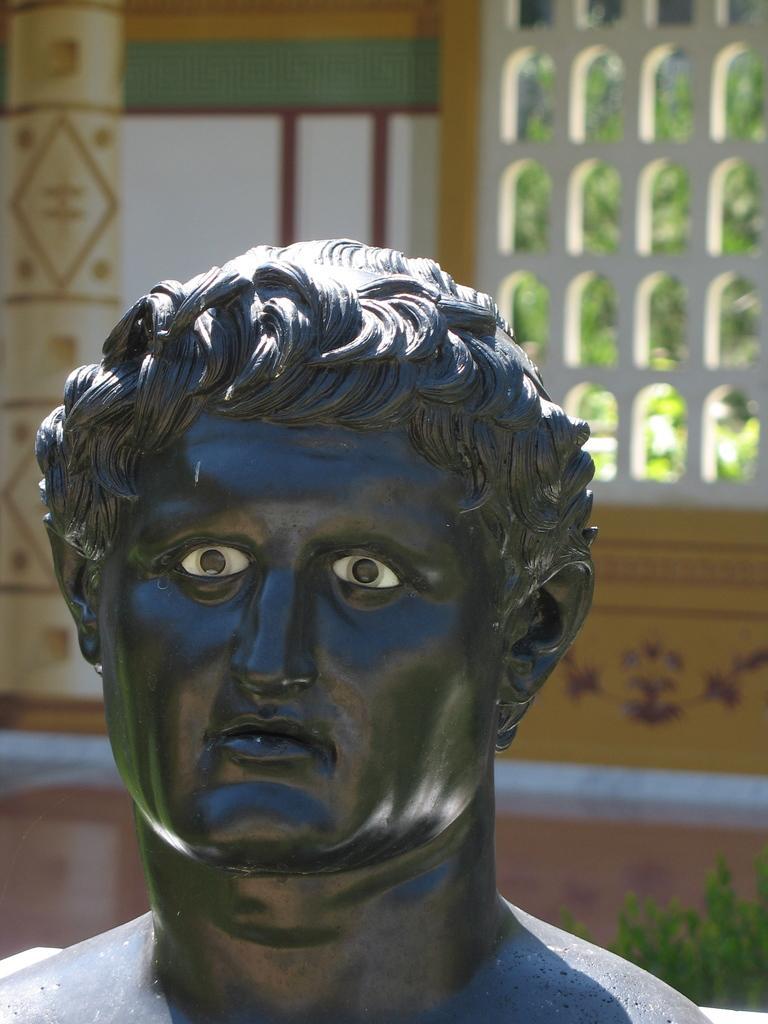Please provide a concise description of this image. We can see sculpture of a person. In the background we can see designed wall, green leaves and window. 